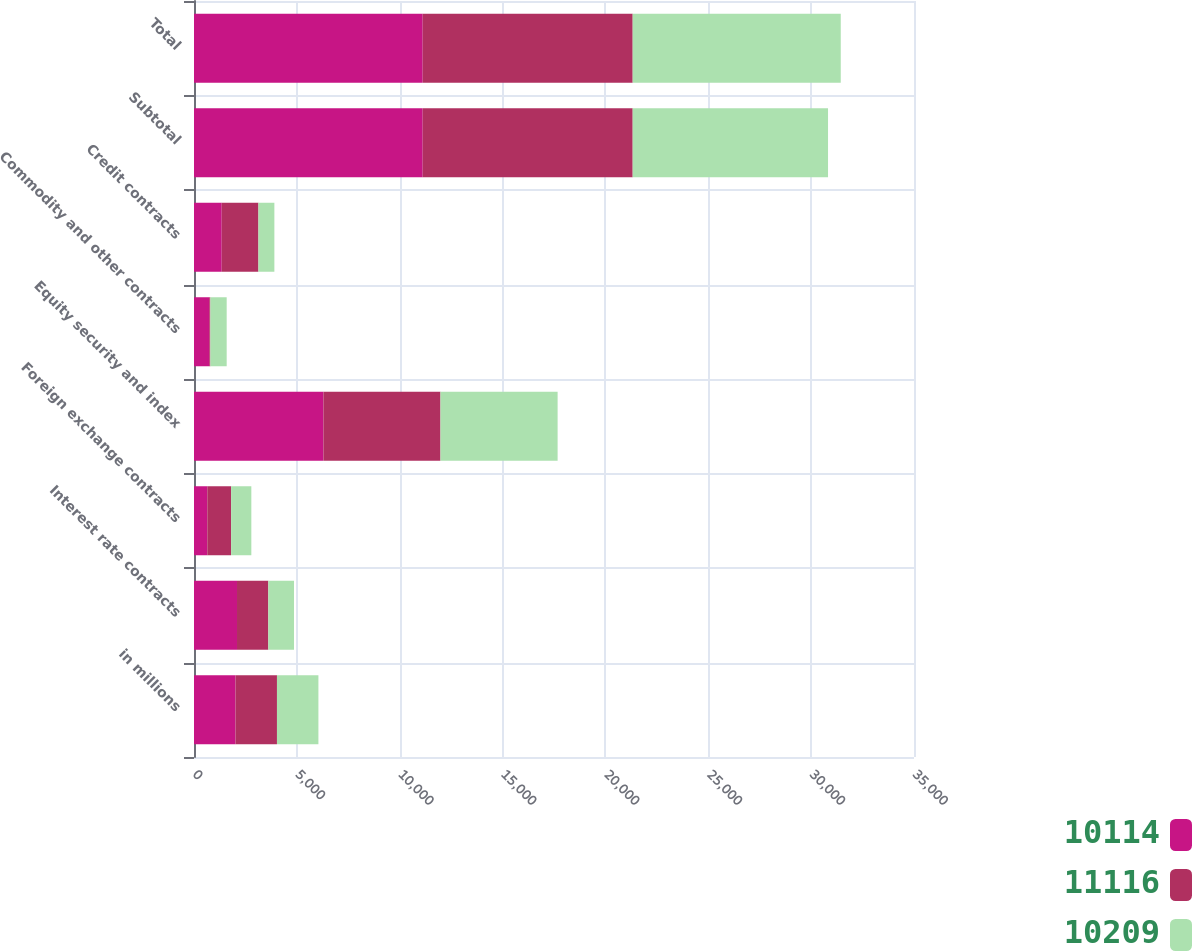Convert chart. <chart><loc_0><loc_0><loc_500><loc_500><stacked_bar_chart><ecel><fcel>in millions<fcel>Interest rate contracts<fcel>Foreign exchange contracts<fcel>Equity security and index<fcel>Commodity and other contracts<fcel>Credit contracts<fcel>Subtotal<fcel>Total<nl><fcel>10114<fcel>2017<fcel>2091<fcel>647<fcel>6291<fcel>740<fcel>1347<fcel>11116<fcel>11116<nl><fcel>11116<fcel>2016<fcel>1522<fcel>1156<fcel>5690<fcel>56<fcel>1785<fcel>10209<fcel>10209<nl><fcel>10209<fcel>2015<fcel>1249<fcel>984<fcel>5695<fcel>793<fcel>775<fcel>9496<fcel>10114<nl></chart> 